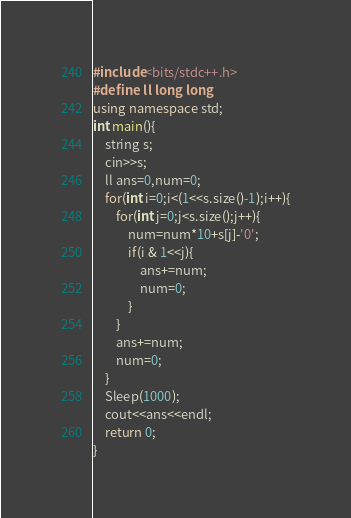<code> <loc_0><loc_0><loc_500><loc_500><_C++_>#include<bits/stdc++.h>
#define ll long long
using namespace std;
int main(){
	string s;
	cin>>s;
	ll ans=0,num=0;
	for(int i=0;i<(1<<s.size()-1);i++){
		for(int j=0;j<s.size();j++){
			num=num*10+s[j]-'0';
			if(i & 1<<j){
				ans+=num;
				num=0;
			}
		}
		ans+=num;
		num=0;
	}
	Sleep(1000);
	cout<<ans<<endl;
	return 0;
}</code> 